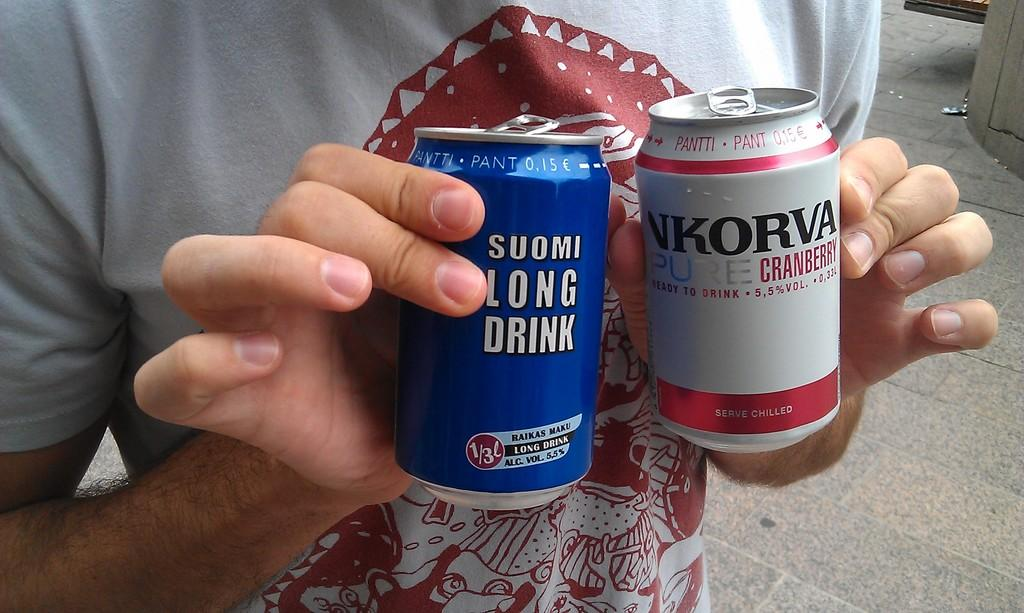<image>
Offer a succinct explanation of the picture presented. A person holding a blue can that reads Soumi Long Drink. 